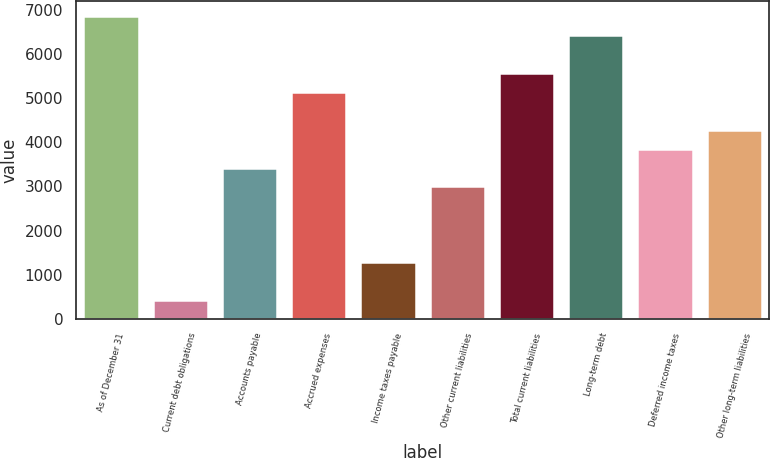Convert chart. <chart><loc_0><loc_0><loc_500><loc_500><bar_chart><fcel>As of December 31<fcel>Current debt obligations<fcel>Accounts payable<fcel>Accrued expenses<fcel>Income taxes payable<fcel>Other current liabilities<fcel>Total current liabilities<fcel>Long-term debt<fcel>Deferred income taxes<fcel>Other long-term liabilities<nl><fcel>6850.6<fcel>429.1<fcel>3425.8<fcel>5138.2<fcel>1285.3<fcel>2997.7<fcel>5566.3<fcel>6422.5<fcel>3853.9<fcel>4282<nl></chart> 